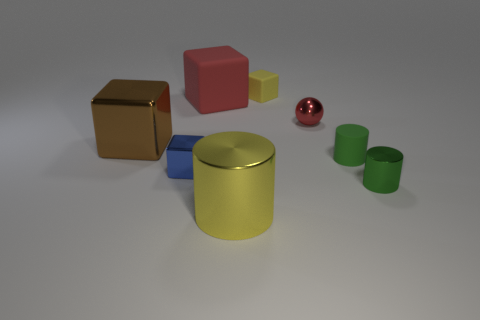How do the textures of the objects compare? The objects present a variety of textures. The yellow and red objects have a matte finish, while the gold and pink cubes have slightly reflective surfaces. The blue object appears to have a satin finish. 